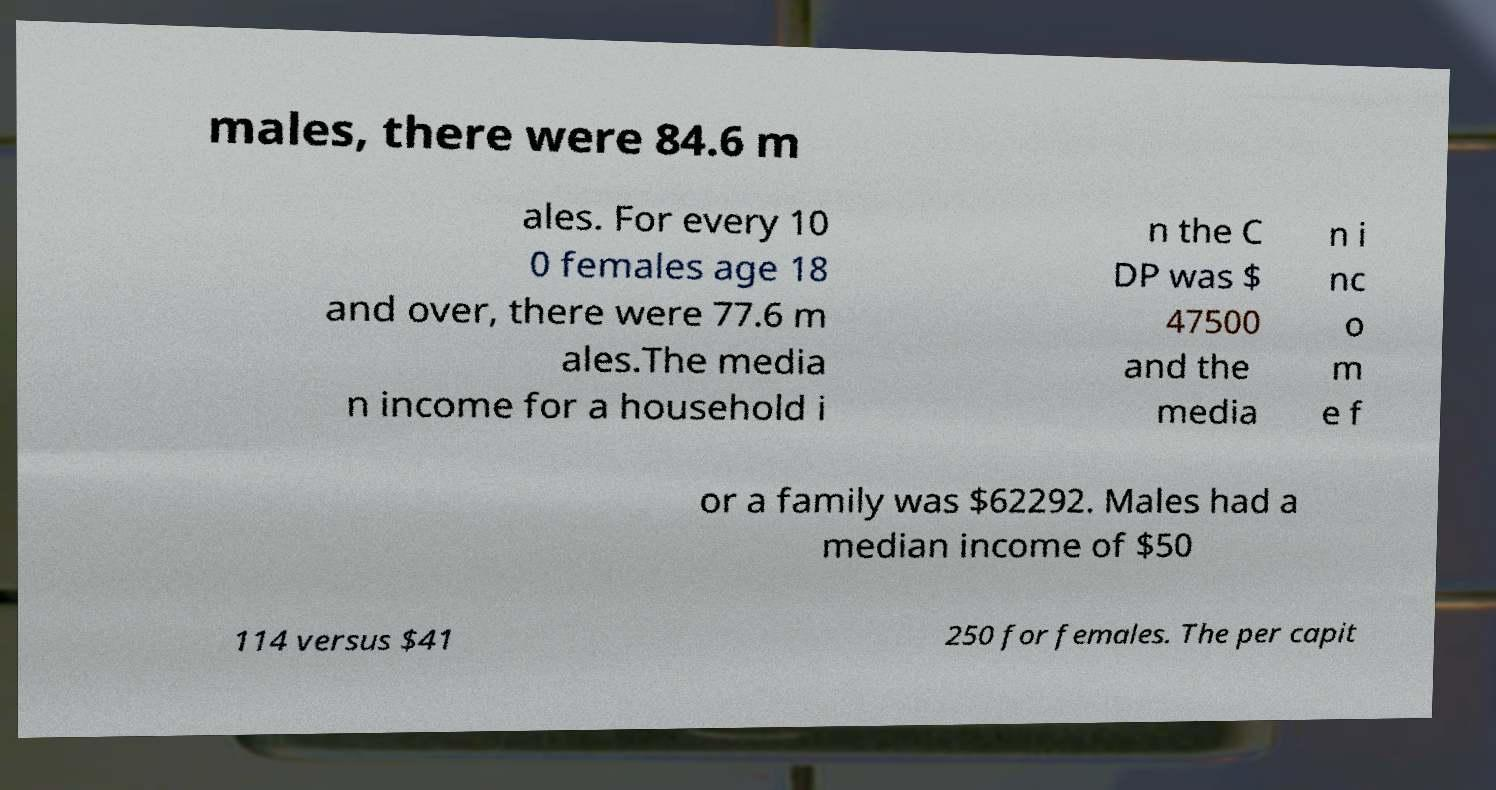Could you extract and type out the text from this image? males, there were 84.6 m ales. For every 10 0 females age 18 and over, there were 77.6 m ales.The media n income for a household i n the C DP was $ 47500 and the media n i nc o m e f or a family was $62292. Males had a median income of $50 114 versus $41 250 for females. The per capit 